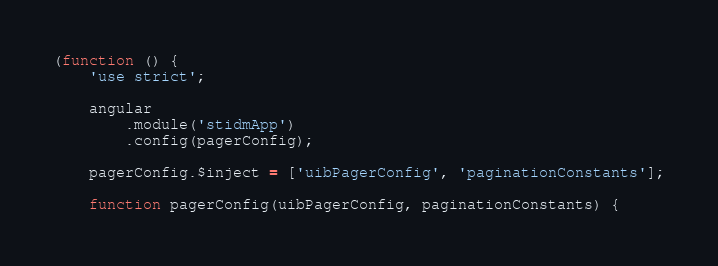Convert code to text. <code><loc_0><loc_0><loc_500><loc_500><_JavaScript_>(function () {
    'use strict';

    angular
        .module('stidmApp')
        .config(pagerConfig);

    pagerConfig.$inject = ['uibPagerConfig', 'paginationConstants'];

    function pagerConfig(uibPagerConfig, paginationConstants) {</code> 